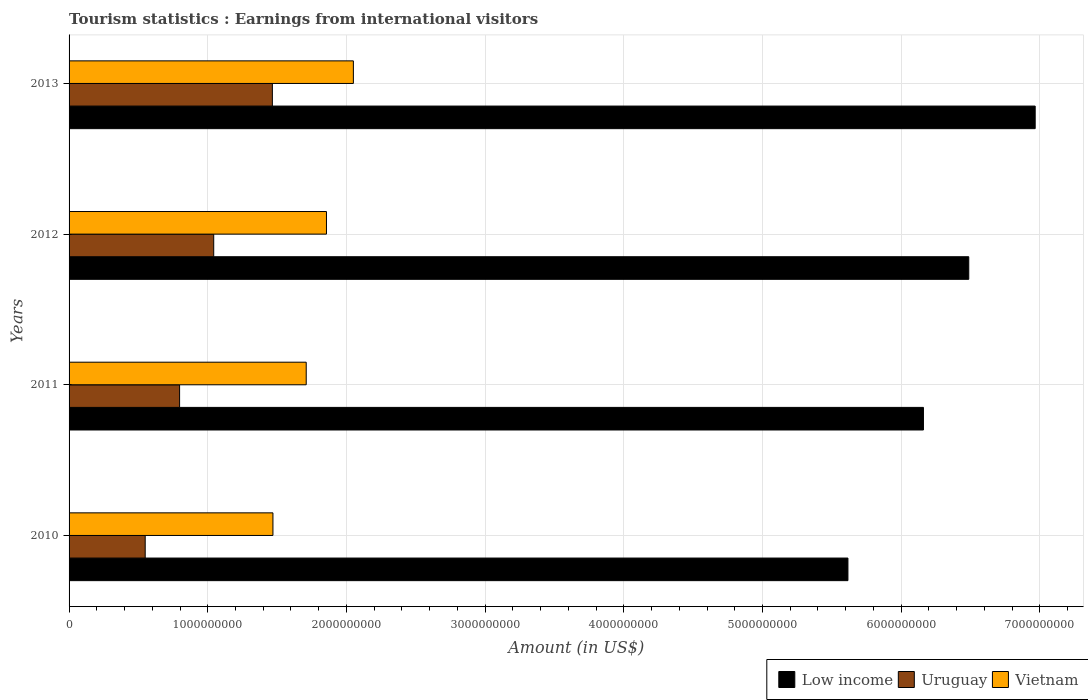How many different coloured bars are there?
Offer a very short reply. 3. How many groups of bars are there?
Make the answer very short. 4. Are the number of bars per tick equal to the number of legend labels?
Your answer should be very brief. Yes. How many bars are there on the 1st tick from the bottom?
Your answer should be very brief. 3. What is the label of the 3rd group of bars from the top?
Ensure brevity in your answer.  2011. In how many cases, is the number of bars for a given year not equal to the number of legend labels?
Provide a short and direct response. 0. What is the earnings from international visitors in Uruguay in 2010?
Provide a succinct answer. 5.49e+08. Across all years, what is the maximum earnings from international visitors in Low income?
Provide a short and direct response. 6.97e+09. Across all years, what is the minimum earnings from international visitors in Uruguay?
Provide a short and direct response. 5.49e+08. In which year was the earnings from international visitors in Low income maximum?
Your answer should be compact. 2013. What is the total earnings from international visitors in Uruguay in the graph?
Give a very brief answer. 3.86e+09. What is the difference between the earnings from international visitors in Low income in 2010 and that in 2013?
Your response must be concise. -1.35e+09. What is the difference between the earnings from international visitors in Vietnam in 2011 and the earnings from international visitors in Low income in 2013?
Ensure brevity in your answer.  -5.26e+09. What is the average earnings from international visitors in Vietnam per year?
Your answer should be very brief. 1.77e+09. In the year 2013, what is the difference between the earnings from international visitors in Low income and earnings from international visitors in Uruguay?
Ensure brevity in your answer.  5.50e+09. What is the ratio of the earnings from international visitors in Low income in 2010 to that in 2011?
Keep it short and to the point. 0.91. Is the difference between the earnings from international visitors in Low income in 2012 and 2013 greater than the difference between the earnings from international visitors in Uruguay in 2012 and 2013?
Give a very brief answer. No. What is the difference between the highest and the second highest earnings from international visitors in Uruguay?
Ensure brevity in your answer.  4.23e+08. What is the difference between the highest and the lowest earnings from international visitors in Low income?
Offer a very short reply. 1.35e+09. In how many years, is the earnings from international visitors in Uruguay greater than the average earnings from international visitors in Uruguay taken over all years?
Ensure brevity in your answer.  2. What does the 2nd bar from the top in 2010 represents?
Your response must be concise. Uruguay. What does the 3rd bar from the bottom in 2010 represents?
Keep it short and to the point. Vietnam. Is it the case that in every year, the sum of the earnings from international visitors in Uruguay and earnings from international visitors in Low income is greater than the earnings from international visitors in Vietnam?
Offer a terse response. Yes. How many bars are there?
Make the answer very short. 12. How many years are there in the graph?
Offer a very short reply. 4. What is the difference between two consecutive major ticks on the X-axis?
Provide a succinct answer. 1.00e+09. Does the graph contain grids?
Make the answer very short. Yes. Where does the legend appear in the graph?
Your response must be concise. Bottom right. How many legend labels are there?
Your answer should be very brief. 3. What is the title of the graph?
Keep it short and to the point. Tourism statistics : Earnings from international visitors. What is the Amount (in US$) in Low income in 2010?
Provide a short and direct response. 5.62e+09. What is the Amount (in US$) in Uruguay in 2010?
Your answer should be very brief. 5.49e+08. What is the Amount (in US$) in Vietnam in 2010?
Your answer should be compact. 1.47e+09. What is the Amount (in US$) in Low income in 2011?
Offer a very short reply. 6.16e+09. What is the Amount (in US$) of Uruguay in 2011?
Your answer should be very brief. 7.97e+08. What is the Amount (in US$) of Vietnam in 2011?
Make the answer very short. 1.71e+09. What is the Amount (in US$) in Low income in 2012?
Offer a very short reply. 6.49e+09. What is the Amount (in US$) of Uruguay in 2012?
Your response must be concise. 1.04e+09. What is the Amount (in US$) of Vietnam in 2012?
Your answer should be very brief. 1.86e+09. What is the Amount (in US$) in Low income in 2013?
Your answer should be compact. 6.97e+09. What is the Amount (in US$) in Uruguay in 2013?
Your response must be concise. 1.47e+09. What is the Amount (in US$) of Vietnam in 2013?
Your response must be concise. 2.05e+09. Across all years, what is the maximum Amount (in US$) of Low income?
Make the answer very short. 6.97e+09. Across all years, what is the maximum Amount (in US$) in Uruguay?
Give a very brief answer. 1.47e+09. Across all years, what is the maximum Amount (in US$) of Vietnam?
Give a very brief answer. 2.05e+09. Across all years, what is the minimum Amount (in US$) of Low income?
Provide a succinct answer. 5.62e+09. Across all years, what is the minimum Amount (in US$) of Uruguay?
Your answer should be very brief. 5.49e+08. Across all years, what is the minimum Amount (in US$) in Vietnam?
Provide a succinct answer. 1.47e+09. What is the total Amount (in US$) of Low income in the graph?
Your answer should be very brief. 2.52e+1. What is the total Amount (in US$) of Uruguay in the graph?
Make the answer very short. 3.86e+09. What is the total Amount (in US$) of Vietnam in the graph?
Offer a terse response. 7.09e+09. What is the difference between the Amount (in US$) of Low income in 2010 and that in 2011?
Your answer should be very brief. -5.44e+08. What is the difference between the Amount (in US$) in Uruguay in 2010 and that in 2011?
Offer a very short reply. -2.48e+08. What is the difference between the Amount (in US$) of Vietnam in 2010 and that in 2011?
Offer a very short reply. -2.40e+08. What is the difference between the Amount (in US$) of Low income in 2010 and that in 2012?
Provide a short and direct response. -8.71e+08. What is the difference between the Amount (in US$) in Uruguay in 2010 and that in 2012?
Ensure brevity in your answer.  -4.94e+08. What is the difference between the Amount (in US$) of Vietnam in 2010 and that in 2012?
Offer a terse response. -3.86e+08. What is the difference between the Amount (in US$) of Low income in 2010 and that in 2013?
Offer a very short reply. -1.35e+09. What is the difference between the Amount (in US$) of Uruguay in 2010 and that in 2013?
Provide a short and direct response. -9.17e+08. What is the difference between the Amount (in US$) in Vietnam in 2010 and that in 2013?
Your answer should be compact. -5.80e+08. What is the difference between the Amount (in US$) in Low income in 2011 and that in 2012?
Your response must be concise. -3.27e+08. What is the difference between the Amount (in US$) in Uruguay in 2011 and that in 2012?
Give a very brief answer. -2.46e+08. What is the difference between the Amount (in US$) in Vietnam in 2011 and that in 2012?
Keep it short and to the point. -1.46e+08. What is the difference between the Amount (in US$) of Low income in 2011 and that in 2013?
Your answer should be very brief. -8.06e+08. What is the difference between the Amount (in US$) of Uruguay in 2011 and that in 2013?
Your response must be concise. -6.69e+08. What is the difference between the Amount (in US$) of Vietnam in 2011 and that in 2013?
Make the answer very short. -3.40e+08. What is the difference between the Amount (in US$) of Low income in 2012 and that in 2013?
Your answer should be very brief. -4.79e+08. What is the difference between the Amount (in US$) in Uruguay in 2012 and that in 2013?
Your answer should be very brief. -4.23e+08. What is the difference between the Amount (in US$) of Vietnam in 2012 and that in 2013?
Ensure brevity in your answer.  -1.94e+08. What is the difference between the Amount (in US$) in Low income in 2010 and the Amount (in US$) in Uruguay in 2011?
Provide a short and direct response. 4.82e+09. What is the difference between the Amount (in US$) of Low income in 2010 and the Amount (in US$) of Vietnam in 2011?
Keep it short and to the point. 3.91e+09. What is the difference between the Amount (in US$) in Uruguay in 2010 and the Amount (in US$) in Vietnam in 2011?
Your response must be concise. -1.16e+09. What is the difference between the Amount (in US$) in Low income in 2010 and the Amount (in US$) in Uruguay in 2012?
Offer a terse response. 4.57e+09. What is the difference between the Amount (in US$) of Low income in 2010 and the Amount (in US$) of Vietnam in 2012?
Provide a succinct answer. 3.76e+09. What is the difference between the Amount (in US$) in Uruguay in 2010 and the Amount (in US$) in Vietnam in 2012?
Give a very brief answer. -1.31e+09. What is the difference between the Amount (in US$) in Low income in 2010 and the Amount (in US$) in Uruguay in 2013?
Give a very brief answer. 4.15e+09. What is the difference between the Amount (in US$) of Low income in 2010 and the Amount (in US$) of Vietnam in 2013?
Provide a short and direct response. 3.57e+09. What is the difference between the Amount (in US$) in Uruguay in 2010 and the Amount (in US$) in Vietnam in 2013?
Provide a succinct answer. -1.50e+09. What is the difference between the Amount (in US$) in Low income in 2011 and the Amount (in US$) in Uruguay in 2012?
Give a very brief answer. 5.12e+09. What is the difference between the Amount (in US$) in Low income in 2011 and the Amount (in US$) in Vietnam in 2012?
Make the answer very short. 4.30e+09. What is the difference between the Amount (in US$) in Uruguay in 2011 and the Amount (in US$) in Vietnam in 2012?
Provide a succinct answer. -1.06e+09. What is the difference between the Amount (in US$) in Low income in 2011 and the Amount (in US$) in Uruguay in 2013?
Your response must be concise. 4.69e+09. What is the difference between the Amount (in US$) in Low income in 2011 and the Amount (in US$) in Vietnam in 2013?
Your answer should be very brief. 4.11e+09. What is the difference between the Amount (in US$) in Uruguay in 2011 and the Amount (in US$) in Vietnam in 2013?
Keep it short and to the point. -1.25e+09. What is the difference between the Amount (in US$) in Low income in 2012 and the Amount (in US$) in Uruguay in 2013?
Offer a very short reply. 5.02e+09. What is the difference between the Amount (in US$) in Low income in 2012 and the Amount (in US$) in Vietnam in 2013?
Your answer should be very brief. 4.44e+09. What is the difference between the Amount (in US$) in Uruguay in 2012 and the Amount (in US$) in Vietnam in 2013?
Provide a succinct answer. -1.01e+09. What is the average Amount (in US$) in Low income per year?
Your response must be concise. 6.31e+09. What is the average Amount (in US$) of Uruguay per year?
Offer a terse response. 9.64e+08. What is the average Amount (in US$) in Vietnam per year?
Give a very brief answer. 1.77e+09. In the year 2010, what is the difference between the Amount (in US$) in Low income and Amount (in US$) in Uruguay?
Your response must be concise. 5.07e+09. In the year 2010, what is the difference between the Amount (in US$) of Low income and Amount (in US$) of Vietnam?
Provide a short and direct response. 4.15e+09. In the year 2010, what is the difference between the Amount (in US$) in Uruguay and Amount (in US$) in Vietnam?
Provide a short and direct response. -9.21e+08. In the year 2011, what is the difference between the Amount (in US$) in Low income and Amount (in US$) in Uruguay?
Provide a short and direct response. 5.36e+09. In the year 2011, what is the difference between the Amount (in US$) of Low income and Amount (in US$) of Vietnam?
Offer a terse response. 4.45e+09. In the year 2011, what is the difference between the Amount (in US$) in Uruguay and Amount (in US$) in Vietnam?
Provide a succinct answer. -9.13e+08. In the year 2012, what is the difference between the Amount (in US$) in Low income and Amount (in US$) in Uruguay?
Make the answer very short. 5.44e+09. In the year 2012, what is the difference between the Amount (in US$) of Low income and Amount (in US$) of Vietnam?
Your answer should be very brief. 4.63e+09. In the year 2012, what is the difference between the Amount (in US$) of Uruguay and Amount (in US$) of Vietnam?
Offer a terse response. -8.13e+08. In the year 2013, what is the difference between the Amount (in US$) in Low income and Amount (in US$) in Uruguay?
Offer a terse response. 5.50e+09. In the year 2013, what is the difference between the Amount (in US$) in Low income and Amount (in US$) in Vietnam?
Provide a short and direct response. 4.92e+09. In the year 2013, what is the difference between the Amount (in US$) in Uruguay and Amount (in US$) in Vietnam?
Provide a short and direct response. -5.84e+08. What is the ratio of the Amount (in US$) in Low income in 2010 to that in 2011?
Your answer should be compact. 0.91. What is the ratio of the Amount (in US$) of Uruguay in 2010 to that in 2011?
Give a very brief answer. 0.69. What is the ratio of the Amount (in US$) of Vietnam in 2010 to that in 2011?
Your answer should be very brief. 0.86. What is the ratio of the Amount (in US$) in Low income in 2010 to that in 2012?
Provide a succinct answer. 0.87. What is the ratio of the Amount (in US$) in Uruguay in 2010 to that in 2012?
Your answer should be compact. 0.53. What is the ratio of the Amount (in US$) in Vietnam in 2010 to that in 2012?
Offer a terse response. 0.79. What is the ratio of the Amount (in US$) in Low income in 2010 to that in 2013?
Your answer should be compact. 0.81. What is the ratio of the Amount (in US$) in Uruguay in 2010 to that in 2013?
Provide a succinct answer. 0.37. What is the ratio of the Amount (in US$) in Vietnam in 2010 to that in 2013?
Ensure brevity in your answer.  0.72. What is the ratio of the Amount (in US$) in Low income in 2011 to that in 2012?
Ensure brevity in your answer.  0.95. What is the ratio of the Amount (in US$) of Uruguay in 2011 to that in 2012?
Make the answer very short. 0.76. What is the ratio of the Amount (in US$) in Vietnam in 2011 to that in 2012?
Make the answer very short. 0.92. What is the ratio of the Amount (in US$) of Low income in 2011 to that in 2013?
Ensure brevity in your answer.  0.88. What is the ratio of the Amount (in US$) in Uruguay in 2011 to that in 2013?
Your answer should be very brief. 0.54. What is the ratio of the Amount (in US$) in Vietnam in 2011 to that in 2013?
Offer a terse response. 0.83. What is the ratio of the Amount (in US$) in Low income in 2012 to that in 2013?
Your answer should be very brief. 0.93. What is the ratio of the Amount (in US$) in Uruguay in 2012 to that in 2013?
Ensure brevity in your answer.  0.71. What is the ratio of the Amount (in US$) of Vietnam in 2012 to that in 2013?
Make the answer very short. 0.91. What is the difference between the highest and the second highest Amount (in US$) in Low income?
Keep it short and to the point. 4.79e+08. What is the difference between the highest and the second highest Amount (in US$) of Uruguay?
Keep it short and to the point. 4.23e+08. What is the difference between the highest and the second highest Amount (in US$) of Vietnam?
Offer a terse response. 1.94e+08. What is the difference between the highest and the lowest Amount (in US$) of Low income?
Your answer should be compact. 1.35e+09. What is the difference between the highest and the lowest Amount (in US$) of Uruguay?
Ensure brevity in your answer.  9.17e+08. What is the difference between the highest and the lowest Amount (in US$) of Vietnam?
Offer a very short reply. 5.80e+08. 